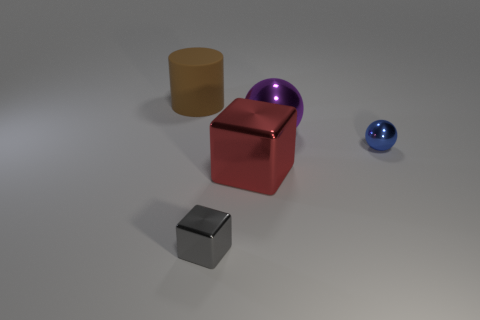Add 5 purple metallic blocks. How many objects exist? 10 Subtract all spheres. How many objects are left? 3 Subtract all big red metal cubes. Subtract all small balls. How many objects are left? 3 Add 3 tiny blue metal spheres. How many tiny blue metal spheres are left? 4 Add 2 big purple spheres. How many big purple spheres exist? 3 Subtract 0 cyan cylinders. How many objects are left? 5 